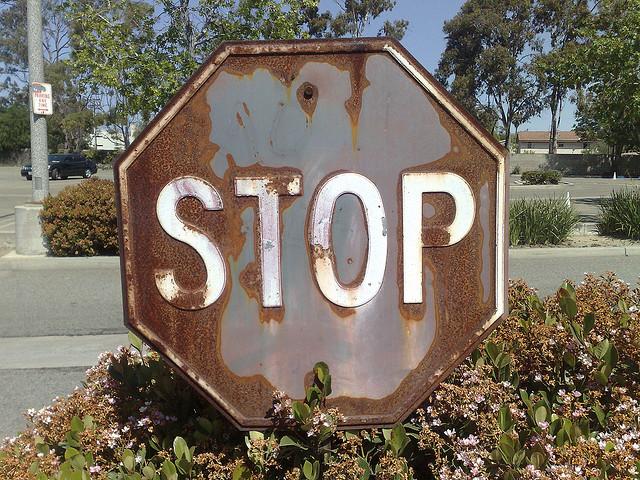Is the parking lot empty?
Short answer required. No. What color should the sign be?
Answer briefly. Red. Does this sign appear to be old?
Concise answer only. Yes. 